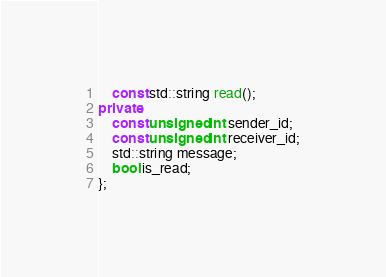<code> <loc_0><loc_0><loc_500><loc_500><_C++_>    const std::string read();
private:
    const unsigned int sender_id;
    const unsigned int receiver_id;
    std::string message;
    bool is_read;
};</code> 